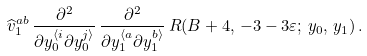<formula> <loc_0><loc_0><loc_500><loc_500>\widehat { v } _ { 1 } ^ { a b } \, \frac { \partial ^ { 2 } } { \partial y _ { 0 } ^ { \langle i } \partial y _ { 0 } ^ { j \rangle } } \, \frac { \partial ^ { 2 } } { \partial y _ { 1 } ^ { \langle a } \partial y _ { 1 } ^ { b \rangle } } \, R ( B + 4 , \, - 3 - 3 \varepsilon ; \, y _ { 0 } , \, y _ { 1 } ) \, .</formula> 